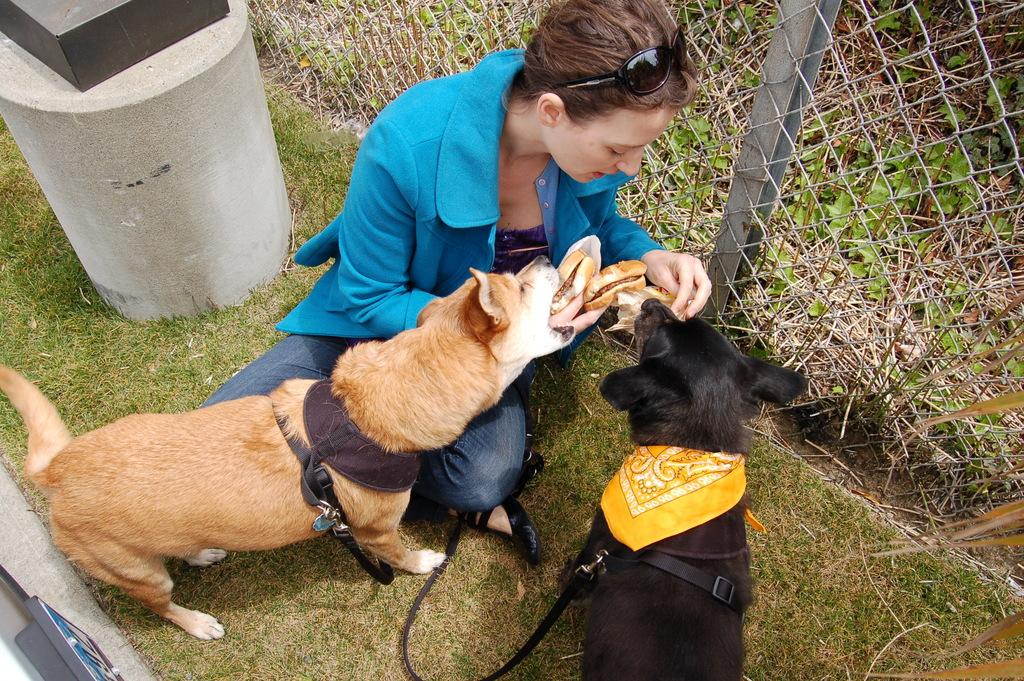What is the woman in the image doing? The woman is sitting and feeding food to dogs in the image. What can be seen on the concrete pole in the image? There is an object on the pole in the image. What type of barrier is present in the image? There is a fence in the image. What type of vegetation is visible in the image? There is grass visible in the image. What type of leather is being used by the servant in the image? There is no servant or leather present in the image. What part of the dog's body is being fed by the woman in the image? The provided facts do not specify which part of the dogs' bodies is being fed, only that the woman is feeding food to dogs. 